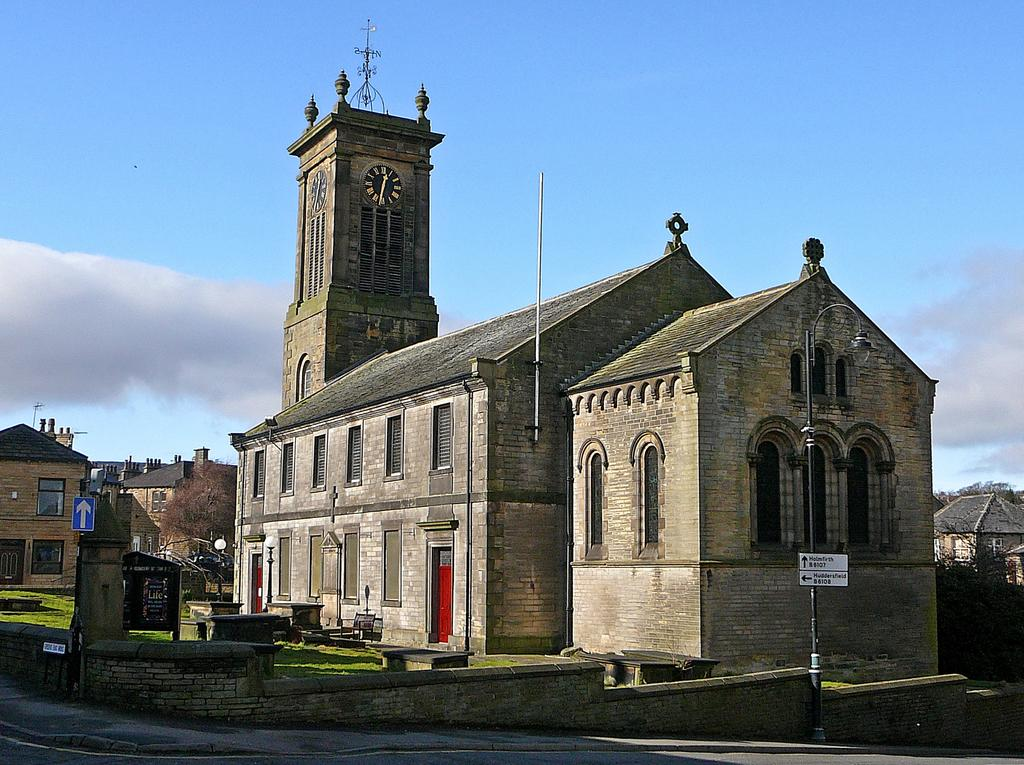What is the main structure in the image? There is a clock tower in the image. What else can be seen in the image besides the clock tower? There are buildings and poles visible in the image. What type of vegetation is present in the image? There is grass visible in the image. What can be seen in the background of the image? The sky is visible in the background of the image. Where is the hospital located in the image? There is no hospital present in the image. Can you see a rake being used in the image? There is no rake visible in the image. 